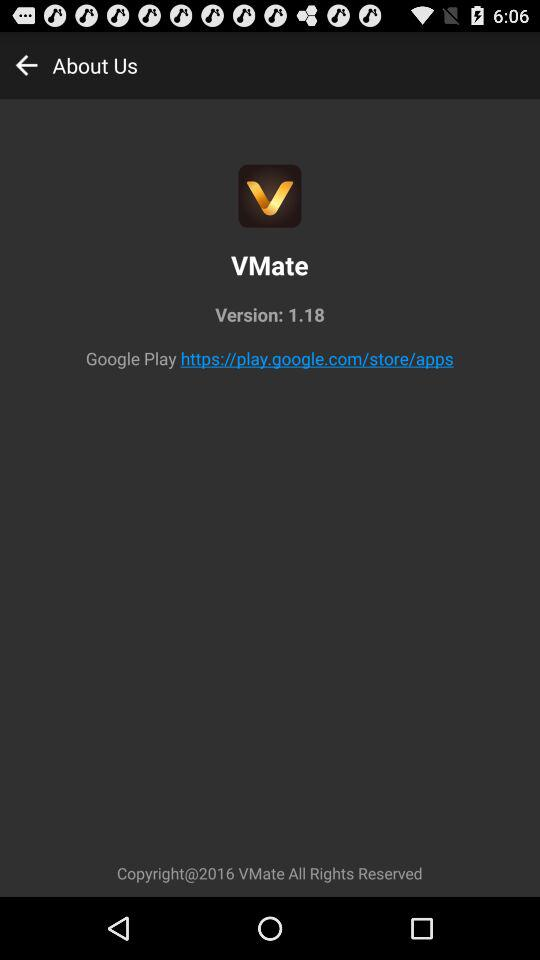What is the version of "VMate"? The version of "VMate" is 1.18. 